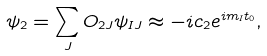Convert formula to latex. <formula><loc_0><loc_0><loc_500><loc_500>\psi _ { 2 } = \sum _ { J } O _ { 2 J } \psi _ { I J } \approx - i c _ { 2 } e ^ { i m _ { I } t _ { 0 } } ,</formula> 